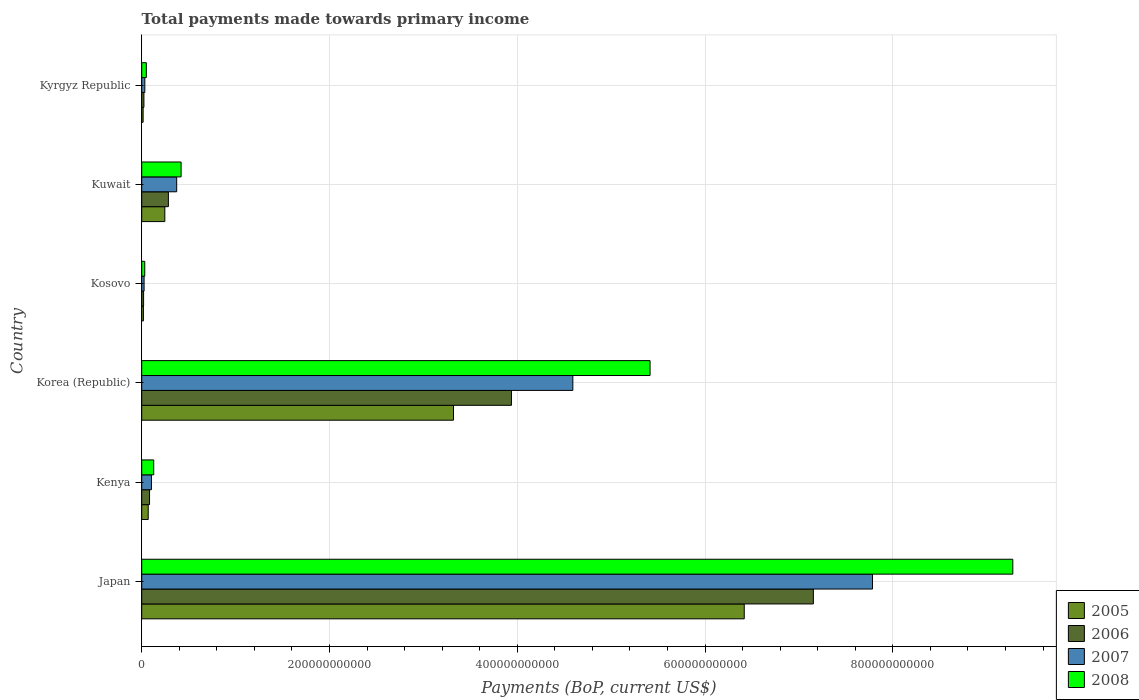How many groups of bars are there?
Your response must be concise. 6. Are the number of bars per tick equal to the number of legend labels?
Offer a very short reply. Yes. How many bars are there on the 5th tick from the top?
Ensure brevity in your answer.  4. How many bars are there on the 4th tick from the bottom?
Offer a very short reply. 4. What is the label of the 3rd group of bars from the top?
Provide a succinct answer. Kosovo. In how many cases, is the number of bars for a given country not equal to the number of legend labels?
Your response must be concise. 0. What is the total payments made towards primary income in 2008 in Japan?
Your answer should be compact. 9.28e+11. Across all countries, what is the maximum total payments made towards primary income in 2005?
Offer a terse response. 6.42e+11. Across all countries, what is the minimum total payments made towards primary income in 2008?
Your response must be concise. 3.22e+09. In which country was the total payments made towards primary income in 2007 maximum?
Provide a succinct answer. Japan. In which country was the total payments made towards primary income in 2006 minimum?
Your answer should be very brief. Kosovo. What is the total total payments made towards primary income in 2008 in the graph?
Your answer should be very brief. 1.53e+12. What is the difference between the total payments made towards primary income in 2008 in Kuwait and that in Kyrgyz Republic?
Make the answer very short. 3.70e+1. What is the difference between the total payments made towards primary income in 2006 in Japan and the total payments made towards primary income in 2005 in Korea (Republic)?
Give a very brief answer. 3.83e+11. What is the average total payments made towards primary income in 2008 per country?
Your answer should be very brief. 2.55e+11. What is the difference between the total payments made towards primary income in 2006 and total payments made towards primary income in 2007 in Kuwait?
Your answer should be compact. -8.83e+09. In how many countries, is the total payments made towards primary income in 2008 greater than 720000000000 US$?
Your response must be concise. 1. What is the ratio of the total payments made towards primary income in 2006 in Kenya to that in Kyrgyz Republic?
Your response must be concise. 3.56. Is the difference between the total payments made towards primary income in 2006 in Japan and Kuwait greater than the difference between the total payments made towards primary income in 2007 in Japan and Kuwait?
Give a very brief answer. No. What is the difference between the highest and the second highest total payments made towards primary income in 2006?
Provide a short and direct response. 3.22e+11. What is the difference between the highest and the lowest total payments made towards primary income in 2006?
Make the answer very short. 7.13e+11. How many bars are there?
Make the answer very short. 24. Are all the bars in the graph horizontal?
Provide a short and direct response. Yes. How many countries are there in the graph?
Your answer should be very brief. 6. What is the difference between two consecutive major ticks on the X-axis?
Ensure brevity in your answer.  2.00e+11. How many legend labels are there?
Ensure brevity in your answer.  4. How are the legend labels stacked?
Ensure brevity in your answer.  Vertical. What is the title of the graph?
Ensure brevity in your answer.  Total payments made towards primary income. What is the label or title of the X-axis?
Provide a succinct answer. Payments (BoP, current US$). What is the Payments (BoP, current US$) in 2005 in Japan?
Keep it short and to the point. 6.42e+11. What is the Payments (BoP, current US$) in 2006 in Japan?
Offer a terse response. 7.15e+11. What is the Payments (BoP, current US$) in 2007 in Japan?
Provide a short and direct response. 7.78e+11. What is the Payments (BoP, current US$) of 2008 in Japan?
Your response must be concise. 9.28e+11. What is the Payments (BoP, current US$) of 2005 in Kenya?
Offer a terse response. 6.92e+09. What is the Payments (BoP, current US$) in 2006 in Kenya?
Give a very brief answer. 8.34e+09. What is the Payments (BoP, current US$) in 2007 in Kenya?
Ensure brevity in your answer.  1.04e+1. What is the Payments (BoP, current US$) in 2008 in Kenya?
Provide a succinct answer. 1.28e+1. What is the Payments (BoP, current US$) of 2005 in Korea (Republic)?
Provide a short and direct response. 3.32e+11. What is the Payments (BoP, current US$) in 2006 in Korea (Republic)?
Offer a terse response. 3.94e+11. What is the Payments (BoP, current US$) of 2007 in Korea (Republic)?
Offer a terse response. 4.59e+11. What is the Payments (BoP, current US$) of 2008 in Korea (Republic)?
Provide a short and direct response. 5.41e+11. What is the Payments (BoP, current US$) of 2005 in Kosovo?
Ensure brevity in your answer.  1.80e+09. What is the Payments (BoP, current US$) in 2006 in Kosovo?
Make the answer very short. 1.99e+09. What is the Payments (BoP, current US$) of 2007 in Kosovo?
Ensure brevity in your answer.  2.53e+09. What is the Payments (BoP, current US$) in 2008 in Kosovo?
Offer a terse response. 3.22e+09. What is the Payments (BoP, current US$) in 2005 in Kuwait?
Provide a short and direct response. 2.46e+1. What is the Payments (BoP, current US$) in 2006 in Kuwait?
Offer a very short reply. 2.84e+1. What is the Payments (BoP, current US$) of 2007 in Kuwait?
Offer a terse response. 3.72e+1. What is the Payments (BoP, current US$) of 2008 in Kuwait?
Ensure brevity in your answer.  4.19e+1. What is the Payments (BoP, current US$) of 2005 in Kyrgyz Republic?
Your response must be concise. 1.50e+09. What is the Payments (BoP, current US$) of 2006 in Kyrgyz Republic?
Give a very brief answer. 2.34e+09. What is the Payments (BoP, current US$) in 2007 in Kyrgyz Republic?
Offer a very short reply. 3.31e+09. What is the Payments (BoP, current US$) in 2008 in Kyrgyz Republic?
Offer a terse response. 4.91e+09. Across all countries, what is the maximum Payments (BoP, current US$) in 2005?
Keep it short and to the point. 6.42e+11. Across all countries, what is the maximum Payments (BoP, current US$) in 2006?
Offer a very short reply. 7.15e+11. Across all countries, what is the maximum Payments (BoP, current US$) of 2007?
Give a very brief answer. 7.78e+11. Across all countries, what is the maximum Payments (BoP, current US$) in 2008?
Ensure brevity in your answer.  9.28e+11. Across all countries, what is the minimum Payments (BoP, current US$) of 2005?
Provide a succinct answer. 1.50e+09. Across all countries, what is the minimum Payments (BoP, current US$) in 2006?
Offer a terse response. 1.99e+09. Across all countries, what is the minimum Payments (BoP, current US$) of 2007?
Offer a very short reply. 2.53e+09. Across all countries, what is the minimum Payments (BoP, current US$) of 2008?
Provide a short and direct response. 3.22e+09. What is the total Payments (BoP, current US$) in 2005 in the graph?
Your answer should be compact. 1.01e+12. What is the total Payments (BoP, current US$) of 2006 in the graph?
Ensure brevity in your answer.  1.15e+12. What is the total Payments (BoP, current US$) of 2007 in the graph?
Provide a short and direct response. 1.29e+12. What is the total Payments (BoP, current US$) in 2008 in the graph?
Give a very brief answer. 1.53e+12. What is the difference between the Payments (BoP, current US$) of 2005 in Japan and that in Kenya?
Make the answer very short. 6.35e+11. What is the difference between the Payments (BoP, current US$) of 2006 in Japan and that in Kenya?
Your answer should be very brief. 7.07e+11. What is the difference between the Payments (BoP, current US$) of 2007 in Japan and that in Kenya?
Your answer should be compact. 7.68e+11. What is the difference between the Payments (BoP, current US$) of 2008 in Japan and that in Kenya?
Offer a very short reply. 9.15e+11. What is the difference between the Payments (BoP, current US$) of 2005 in Japan and that in Korea (Republic)?
Offer a terse response. 3.10e+11. What is the difference between the Payments (BoP, current US$) in 2006 in Japan and that in Korea (Republic)?
Your answer should be very brief. 3.22e+11. What is the difference between the Payments (BoP, current US$) of 2007 in Japan and that in Korea (Republic)?
Offer a terse response. 3.19e+11. What is the difference between the Payments (BoP, current US$) in 2008 in Japan and that in Korea (Republic)?
Ensure brevity in your answer.  3.86e+11. What is the difference between the Payments (BoP, current US$) in 2005 in Japan and that in Kosovo?
Your response must be concise. 6.40e+11. What is the difference between the Payments (BoP, current US$) in 2006 in Japan and that in Kosovo?
Ensure brevity in your answer.  7.13e+11. What is the difference between the Payments (BoP, current US$) in 2007 in Japan and that in Kosovo?
Offer a very short reply. 7.76e+11. What is the difference between the Payments (BoP, current US$) of 2008 in Japan and that in Kosovo?
Your response must be concise. 9.25e+11. What is the difference between the Payments (BoP, current US$) in 2005 in Japan and that in Kuwait?
Provide a succinct answer. 6.17e+11. What is the difference between the Payments (BoP, current US$) in 2006 in Japan and that in Kuwait?
Offer a very short reply. 6.87e+11. What is the difference between the Payments (BoP, current US$) of 2007 in Japan and that in Kuwait?
Provide a succinct answer. 7.41e+11. What is the difference between the Payments (BoP, current US$) of 2008 in Japan and that in Kuwait?
Provide a succinct answer. 8.86e+11. What is the difference between the Payments (BoP, current US$) of 2005 in Japan and that in Kyrgyz Republic?
Provide a succinct answer. 6.40e+11. What is the difference between the Payments (BoP, current US$) of 2006 in Japan and that in Kyrgyz Republic?
Your answer should be compact. 7.13e+11. What is the difference between the Payments (BoP, current US$) of 2007 in Japan and that in Kyrgyz Republic?
Offer a very short reply. 7.75e+11. What is the difference between the Payments (BoP, current US$) in 2008 in Japan and that in Kyrgyz Republic?
Offer a very short reply. 9.23e+11. What is the difference between the Payments (BoP, current US$) of 2005 in Kenya and that in Korea (Republic)?
Make the answer very short. -3.25e+11. What is the difference between the Payments (BoP, current US$) of 2006 in Kenya and that in Korea (Republic)?
Provide a short and direct response. -3.85e+11. What is the difference between the Payments (BoP, current US$) in 2007 in Kenya and that in Korea (Republic)?
Keep it short and to the point. -4.49e+11. What is the difference between the Payments (BoP, current US$) of 2008 in Kenya and that in Korea (Republic)?
Give a very brief answer. -5.29e+11. What is the difference between the Payments (BoP, current US$) in 2005 in Kenya and that in Kosovo?
Offer a very short reply. 5.12e+09. What is the difference between the Payments (BoP, current US$) in 2006 in Kenya and that in Kosovo?
Keep it short and to the point. 6.35e+09. What is the difference between the Payments (BoP, current US$) in 2007 in Kenya and that in Kosovo?
Give a very brief answer. 7.84e+09. What is the difference between the Payments (BoP, current US$) of 2008 in Kenya and that in Kosovo?
Ensure brevity in your answer.  9.56e+09. What is the difference between the Payments (BoP, current US$) in 2005 in Kenya and that in Kuwait?
Provide a short and direct response. -1.77e+1. What is the difference between the Payments (BoP, current US$) of 2006 in Kenya and that in Kuwait?
Offer a terse response. -2.01e+1. What is the difference between the Payments (BoP, current US$) in 2007 in Kenya and that in Kuwait?
Offer a very short reply. -2.69e+1. What is the difference between the Payments (BoP, current US$) of 2008 in Kenya and that in Kuwait?
Your answer should be very brief. -2.92e+1. What is the difference between the Payments (BoP, current US$) of 2005 in Kenya and that in Kyrgyz Republic?
Your answer should be compact. 5.42e+09. What is the difference between the Payments (BoP, current US$) in 2006 in Kenya and that in Kyrgyz Republic?
Ensure brevity in your answer.  6.00e+09. What is the difference between the Payments (BoP, current US$) of 2007 in Kenya and that in Kyrgyz Republic?
Your response must be concise. 7.05e+09. What is the difference between the Payments (BoP, current US$) of 2008 in Kenya and that in Kyrgyz Republic?
Offer a very short reply. 7.87e+09. What is the difference between the Payments (BoP, current US$) of 2005 in Korea (Republic) and that in Kosovo?
Ensure brevity in your answer.  3.30e+11. What is the difference between the Payments (BoP, current US$) of 2006 in Korea (Republic) and that in Kosovo?
Offer a terse response. 3.92e+11. What is the difference between the Payments (BoP, current US$) of 2007 in Korea (Republic) and that in Kosovo?
Give a very brief answer. 4.57e+11. What is the difference between the Payments (BoP, current US$) of 2008 in Korea (Republic) and that in Kosovo?
Offer a terse response. 5.38e+11. What is the difference between the Payments (BoP, current US$) in 2005 in Korea (Republic) and that in Kuwait?
Your answer should be very brief. 3.07e+11. What is the difference between the Payments (BoP, current US$) of 2006 in Korea (Republic) and that in Kuwait?
Your response must be concise. 3.65e+11. What is the difference between the Payments (BoP, current US$) of 2007 in Korea (Republic) and that in Kuwait?
Keep it short and to the point. 4.22e+11. What is the difference between the Payments (BoP, current US$) of 2008 in Korea (Republic) and that in Kuwait?
Offer a terse response. 5.00e+11. What is the difference between the Payments (BoP, current US$) in 2005 in Korea (Republic) and that in Kyrgyz Republic?
Your answer should be compact. 3.31e+11. What is the difference between the Payments (BoP, current US$) in 2006 in Korea (Republic) and that in Kyrgyz Republic?
Offer a very short reply. 3.91e+11. What is the difference between the Payments (BoP, current US$) of 2007 in Korea (Republic) and that in Kyrgyz Republic?
Your answer should be very brief. 4.56e+11. What is the difference between the Payments (BoP, current US$) of 2008 in Korea (Republic) and that in Kyrgyz Republic?
Your answer should be very brief. 5.37e+11. What is the difference between the Payments (BoP, current US$) of 2005 in Kosovo and that in Kuwait?
Give a very brief answer. -2.28e+1. What is the difference between the Payments (BoP, current US$) in 2006 in Kosovo and that in Kuwait?
Ensure brevity in your answer.  -2.64e+1. What is the difference between the Payments (BoP, current US$) of 2007 in Kosovo and that in Kuwait?
Ensure brevity in your answer.  -3.47e+1. What is the difference between the Payments (BoP, current US$) in 2008 in Kosovo and that in Kuwait?
Make the answer very short. -3.87e+1. What is the difference between the Payments (BoP, current US$) in 2005 in Kosovo and that in Kyrgyz Republic?
Provide a succinct answer. 3.03e+08. What is the difference between the Payments (BoP, current US$) in 2006 in Kosovo and that in Kyrgyz Republic?
Offer a very short reply. -3.55e+08. What is the difference between the Payments (BoP, current US$) in 2007 in Kosovo and that in Kyrgyz Republic?
Offer a very short reply. -7.83e+08. What is the difference between the Payments (BoP, current US$) in 2008 in Kosovo and that in Kyrgyz Republic?
Give a very brief answer. -1.69e+09. What is the difference between the Payments (BoP, current US$) of 2005 in Kuwait and that in Kyrgyz Republic?
Ensure brevity in your answer.  2.31e+1. What is the difference between the Payments (BoP, current US$) of 2006 in Kuwait and that in Kyrgyz Republic?
Ensure brevity in your answer.  2.61e+1. What is the difference between the Payments (BoP, current US$) in 2007 in Kuwait and that in Kyrgyz Republic?
Your response must be concise. 3.39e+1. What is the difference between the Payments (BoP, current US$) of 2008 in Kuwait and that in Kyrgyz Republic?
Offer a terse response. 3.70e+1. What is the difference between the Payments (BoP, current US$) in 2005 in Japan and the Payments (BoP, current US$) in 2006 in Kenya?
Offer a terse response. 6.33e+11. What is the difference between the Payments (BoP, current US$) of 2005 in Japan and the Payments (BoP, current US$) of 2007 in Kenya?
Ensure brevity in your answer.  6.31e+11. What is the difference between the Payments (BoP, current US$) of 2005 in Japan and the Payments (BoP, current US$) of 2008 in Kenya?
Keep it short and to the point. 6.29e+11. What is the difference between the Payments (BoP, current US$) in 2006 in Japan and the Payments (BoP, current US$) in 2007 in Kenya?
Your response must be concise. 7.05e+11. What is the difference between the Payments (BoP, current US$) in 2006 in Japan and the Payments (BoP, current US$) in 2008 in Kenya?
Provide a succinct answer. 7.03e+11. What is the difference between the Payments (BoP, current US$) of 2007 in Japan and the Payments (BoP, current US$) of 2008 in Kenya?
Offer a terse response. 7.66e+11. What is the difference between the Payments (BoP, current US$) of 2005 in Japan and the Payments (BoP, current US$) of 2006 in Korea (Republic)?
Your answer should be very brief. 2.48e+11. What is the difference between the Payments (BoP, current US$) of 2005 in Japan and the Payments (BoP, current US$) of 2007 in Korea (Republic)?
Your answer should be compact. 1.83e+11. What is the difference between the Payments (BoP, current US$) of 2005 in Japan and the Payments (BoP, current US$) of 2008 in Korea (Republic)?
Keep it short and to the point. 1.00e+11. What is the difference between the Payments (BoP, current US$) in 2006 in Japan and the Payments (BoP, current US$) in 2007 in Korea (Republic)?
Your answer should be very brief. 2.56e+11. What is the difference between the Payments (BoP, current US$) of 2006 in Japan and the Payments (BoP, current US$) of 2008 in Korea (Republic)?
Your answer should be compact. 1.74e+11. What is the difference between the Payments (BoP, current US$) in 2007 in Japan and the Payments (BoP, current US$) in 2008 in Korea (Republic)?
Ensure brevity in your answer.  2.37e+11. What is the difference between the Payments (BoP, current US$) in 2005 in Japan and the Payments (BoP, current US$) in 2006 in Kosovo?
Make the answer very short. 6.40e+11. What is the difference between the Payments (BoP, current US$) in 2005 in Japan and the Payments (BoP, current US$) in 2007 in Kosovo?
Offer a terse response. 6.39e+11. What is the difference between the Payments (BoP, current US$) of 2005 in Japan and the Payments (BoP, current US$) of 2008 in Kosovo?
Your answer should be very brief. 6.39e+11. What is the difference between the Payments (BoP, current US$) in 2006 in Japan and the Payments (BoP, current US$) in 2007 in Kosovo?
Offer a very short reply. 7.13e+11. What is the difference between the Payments (BoP, current US$) in 2006 in Japan and the Payments (BoP, current US$) in 2008 in Kosovo?
Offer a very short reply. 7.12e+11. What is the difference between the Payments (BoP, current US$) in 2007 in Japan and the Payments (BoP, current US$) in 2008 in Kosovo?
Make the answer very short. 7.75e+11. What is the difference between the Payments (BoP, current US$) in 2005 in Japan and the Payments (BoP, current US$) in 2006 in Kuwait?
Your response must be concise. 6.13e+11. What is the difference between the Payments (BoP, current US$) of 2005 in Japan and the Payments (BoP, current US$) of 2007 in Kuwait?
Provide a short and direct response. 6.05e+11. What is the difference between the Payments (BoP, current US$) of 2005 in Japan and the Payments (BoP, current US$) of 2008 in Kuwait?
Your response must be concise. 6.00e+11. What is the difference between the Payments (BoP, current US$) in 2006 in Japan and the Payments (BoP, current US$) in 2007 in Kuwait?
Offer a very short reply. 6.78e+11. What is the difference between the Payments (BoP, current US$) of 2006 in Japan and the Payments (BoP, current US$) of 2008 in Kuwait?
Give a very brief answer. 6.73e+11. What is the difference between the Payments (BoP, current US$) in 2007 in Japan and the Payments (BoP, current US$) in 2008 in Kuwait?
Your answer should be compact. 7.36e+11. What is the difference between the Payments (BoP, current US$) of 2005 in Japan and the Payments (BoP, current US$) of 2006 in Kyrgyz Republic?
Provide a short and direct response. 6.39e+11. What is the difference between the Payments (BoP, current US$) of 2005 in Japan and the Payments (BoP, current US$) of 2007 in Kyrgyz Republic?
Offer a terse response. 6.38e+11. What is the difference between the Payments (BoP, current US$) in 2005 in Japan and the Payments (BoP, current US$) in 2008 in Kyrgyz Republic?
Provide a succinct answer. 6.37e+11. What is the difference between the Payments (BoP, current US$) of 2006 in Japan and the Payments (BoP, current US$) of 2007 in Kyrgyz Republic?
Give a very brief answer. 7.12e+11. What is the difference between the Payments (BoP, current US$) in 2006 in Japan and the Payments (BoP, current US$) in 2008 in Kyrgyz Republic?
Your answer should be compact. 7.10e+11. What is the difference between the Payments (BoP, current US$) of 2007 in Japan and the Payments (BoP, current US$) of 2008 in Kyrgyz Republic?
Your response must be concise. 7.73e+11. What is the difference between the Payments (BoP, current US$) in 2005 in Kenya and the Payments (BoP, current US$) in 2006 in Korea (Republic)?
Your response must be concise. -3.87e+11. What is the difference between the Payments (BoP, current US$) of 2005 in Kenya and the Payments (BoP, current US$) of 2007 in Korea (Republic)?
Your answer should be compact. -4.52e+11. What is the difference between the Payments (BoP, current US$) of 2005 in Kenya and the Payments (BoP, current US$) of 2008 in Korea (Republic)?
Ensure brevity in your answer.  -5.35e+11. What is the difference between the Payments (BoP, current US$) in 2006 in Kenya and the Payments (BoP, current US$) in 2007 in Korea (Republic)?
Your answer should be compact. -4.51e+11. What is the difference between the Payments (BoP, current US$) in 2006 in Kenya and the Payments (BoP, current US$) in 2008 in Korea (Republic)?
Make the answer very short. -5.33e+11. What is the difference between the Payments (BoP, current US$) of 2007 in Kenya and the Payments (BoP, current US$) of 2008 in Korea (Republic)?
Your answer should be compact. -5.31e+11. What is the difference between the Payments (BoP, current US$) in 2005 in Kenya and the Payments (BoP, current US$) in 2006 in Kosovo?
Your answer should be compact. 4.93e+09. What is the difference between the Payments (BoP, current US$) in 2005 in Kenya and the Payments (BoP, current US$) in 2007 in Kosovo?
Offer a very short reply. 4.39e+09. What is the difference between the Payments (BoP, current US$) in 2005 in Kenya and the Payments (BoP, current US$) in 2008 in Kosovo?
Provide a short and direct response. 3.70e+09. What is the difference between the Payments (BoP, current US$) in 2006 in Kenya and the Payments (BoP, current US$) in 2007 in Kosovo?
Ensure brevity in your answer.  5.81e+09. What is the difference between the Payments (BoP, current US$) of 2006 in Kenya and the Payments (BoP, current US$) of 2008 in Kosovo?
Your answer should be compact. 5.12e+09. What is the difference between the Payments (BoP, current US$) in 2007 in Kenya and the Payments (BoP, current US$) in 2008 in Kosovo?
Make the answer very short. 7.14e+09. What is the difference between the Payments (BoP, current US$) in 2005 in Kenya and the Payments (BoP, current US$) in 2006 in Kuwait?
Make the answer very short. -2.15e+1. What is the difference between the Payments (BoP, current US$) in 2005 in Kenya and the Payments (BoP, current US$) in 2007 in Kuwait?
Provide a succinct answer. -3.03e+1. What is the difference between the Payments (BoP, current US$) of 2005 in Kenya and the Payments (BoP, current US$) of 2008 in Kuwait?
Offer a very short reply. -3.50e+1. What is the difference between the Payments (BoP, current US$) in 2006 in Kenya and the Payments (BoP, current US$) in 2007 in Kuwait?
Your answer should be very brief. -2.89e+1. What is the difference between the Payments (BoP, current US$) in 2006 in Kenya and the Payments (BoP, current US$) in 2008 in Kuwait?
Offer a terse response. -3.36e+1. What is the difference between the Payments (BoP, current US$) in 2007 in Kenya and the Payments (BoP, current US$) in 2008 in Kuwait?
Offer a very short reply. -3.16e+1. What is the difference between the Payments (BoP, current US$) in 2005 in Kenya and the Payments (BoP, current US$) in 2006 in Kyrgyz Republic?
Ensure brevity in your answer.  4.58e+09. What is the difference between the Payments (BoP, current US$) of 2005 in Kenya and the Payments (BoP, current US$) of 2007 in Kyrgyz Republic?
Offer a very short reply. 3.61e+09. What is the difference between the Payments (BoP, current US$) in 2005 in Kenya and the Payments (BoP, current US$) in 2008 in Kyrgyz Republic?
Offer a terse response. 2.01e+09. What is the difference between the Payments (BoP, current US$) of 2006 in Kenya and the Payments (BoP, current US$) of 2007 in Kyrgyz Republic?
Provide a short and direct response. 5.03e+09. What is the difference between the Payments (BoP, current US$) of 2006 in Kenya and the Payments (BoP, current US$) of 2008 in Kyrgyz Republic?
Your response must be concise. 3.43e+09. What is the difference between the Payments (BoP, current US$) in 2007 in Kenya and the Payments (BoP, current US$) in 2008 in Kyrgyz Republic?
Offer a terse response. 5.45e+09. What is the difference between the Payments (BoP, current US$) of 2005 in Korea (Republic) and the Payments (BoP, current US$) of 2006 in Kosovo?
Your response must be concise. 3.30e+11. What is the difference between the Payments (BoP, current US$) of 2005 in Korea (Republic) and the Payments (BoP, current US$) of 2007 in Kosovo?
Make the answer very short. 3.30e+11. What is the difference between the Payments (BoP, current US$) of 2005 in Korea (Republic) and the Payments (BoP, current US$) of 2008 in Kosovo?
Provide a short and direct response. 3.29e+11. What is the difference between the Payments (BoP, current US$) in 2006 in Korea (Republic) and the Payments (BoP, current US$) in 2007 in Kosovo?
Give a very brief answer. 3.91e+11. What is the difference between the Payments (BoP, current US$) of 2006 in Korea (Republic) and the Payments (BoP, current US$) of 2008 in Kosovo?
Offer a terse response. 3.91e+11. What is the difference between the Payments (BoP, current US$) in 2007 in Korea (Republic) and the Payments (BoP, current US$) in 2008 in Kosovo?
Keep it short and to the point. 4.56e+11. What is the difference between the Payments (BoP, current US$) of 2005 in Korea (Republic) and the Payments (BoP, current US$) of 2006 in Kuwait?
Provide a short and direct response. 3.04e+11. What is the difference between the Payments (BoP, current US$) of 2005 in Korea (Republic) and the Payments (BoP, current US$) of 2007 in Kuwait?
Give a very brief answer. 2.95e+11. What is the difference between the Payments (BoP, current US$) of 2005 in Korea (Republic) and the Payments (BoP, current US$) of 2008 in Kuwait?
Provide a short and direct response. 2.90e+11. What is the difference between the Payments (BoP, current US$) of 2006 in Korea (Republic) and the Payments (BoP, current US$) of 2007 in Kuwait?
Make the answer very short. 3.57e+11. What is the difference between the Payments (BoP, current US$) in 2006 in Korea (Republic) and the Payments (BoP, current US$) in 2008 in Kuwait?
Make the answer very short. 3.52e+11. What is the difference between the Payments (BoP, current US$) in 2007 in Korea (Republic) and the Payments (BoP, current US$) in 2008 in Kuwait?
Provide a succinct answer. 4.17e+11. What is the difference between the Payments (BoP, current US$) in 2005 in Korea (Republic) and the Payments (BoP, current US$) in 2006 in Kyrgyz Republic?
Give a very brief answer. 3.30e+11. What is the difference between the Payments (BoP, current US$) in 2005 in Korea (Republic) and the Payments (BoP, current US$) in 2007 in Kyrgyz Republic?
Provide a short and direct response. 3.29e+11. What is the difference between the Payments (BoP, current US$) of 2005 in Korea (Republic) and the Payments (BoP, current US$) of 2008 in Kyrgyz Republic?
Offer a terse response. 3.27e+11. What is the difference between the Payments (BoP, current US$) of 2006 in Korea (Republic) and the Payments (BoP, current US$) of 2007 in Kyrgyz Republic?
Provide a short and direct response. 3.91e+11. What is the difference between the Payments (BoP, current US$) of 2006 in Korea (Republic) and the Payments (BoP, current US$) of 2008 in Kyrgyz Republic?
Provide a short and direct response. 3.89e+11. What is the difference between the Payments (BoP, current US$) in 2007 in Korea (Republic) and the Payments (BoP, current US$) in 2008 in Kyrgyz Republic?
Provide a succinct answer. 4.54e+11. What is the difference between the Payments (BoP, current US$) in 2005 in Kosovo and the Payments (BoP, current US$) in 2006 in Kuwait?
Your response must be concise. -2.66e+1. What is the difference between the Payments (BoP, current US$) of 2005 in Kosovo and the Payments (BoP, current US$) of 2007 in Kuwait?
Provide a succinct answer. -3.54e+1. What is the difference between the Payments (BoP, current US$) of 2005 in Kosovo and the Payments (BoP, current US$) of 2008 in Kuwait?
Make the answer very short. -4.01e+1. What is the difference between the Payments (BoP, current US$) of 2006 in Kosovo and the Payments (BoP, current US$) of 2007 in Kuwait?
Ensure brevity in your answer.  -3.53e+1. What is the difference between the Payments (BoP, current US$) in 2006 in Kosovo and the Payments (BoP, current US$) in 2008 in Kuwait?
Provide a short and direct response. -3.99e+1. What is the difference between the Payments (BoP, current US$) in 2007 in Kosovo and the Payments (BoP, current US$) in 2008 in Kuwait?
Make the answer very short. -3.94e+1. What is the difference between the Payments (BoP, current US$) in 2005 in Kosovo and the Payments (BoP, current US$) in 2006 in Kyrgyz Republic?
Make the answer very short. -5.39e+08. What is the difference between the Payments (BoP, current US$) of 2005 in Kosovo and the Payments (BoP, current US$) of 2007 in Kyrgyz Republic?
Keep it short and to the point. -1.51e+09. What is the difference between the Payments (BoP, current US$) of 2005 in Kosovo and the Payments (BoP, current US$) of 2008 in Kyrgyz Republic?
Your response must be concise. -3.11e+09. What is the difference between the Payments (BoP, current US$) of 2006 in Kosovo and the Payments (BoP, current US$) of 2007 in Kyrgyz Republic?
Your response must be concise. -1.32e+09. What is the difference between the Payments (BoP, current US$) in 2006 in Kosovo and the Payments (BoP, current US$) in 2008 in Kyrgyz Republic?
Offer a terse response. -2.93e+09. What is the difference between the Payments (BoP, current US$) in 2007 in Kosovo and the Payments (BoP, current US$) in 2008 in Kyrgyz Republic?
Keep it short and to the point. -2.38e+09. What is the difference between the Payments (BoP, current US$) of 2005 in Kuwait and the Payments (BoP, current US$) of 2006 in Kyrgyz Republic?
Make the answer very short. 2.23e+1. What is the difference between the Payments (BoP, current US$) in 2005 in Kuwait and the Payments (BoP, current US$) in 2007 in Kyrgyz Republic?
Provide a short and direct response. 2.13e+1. What is the difference between the Payments (BoP, current US$) in 2005 in Kuwait and the Payments (BoP, current US$) in 2008 in Kyrgyz Republic?
Your answer should be very brief. 1.97e+1. What is the difference between the Payments (BoP, current US$) of 2006 in Kuwait and the Payments (BoP, current US$) of 2007 in Kyrgyz Republic?
Your answer should be compact. 2.51e+1. What is the difference between the Payments (BoP, current US$) of 2006 in Kuwait and the Payments (BoP, current US$) of 2008 in Kyrgyz Republic?
Your answer should be very brief. 2.35e+1. What is the difference between the Payments (BoP, current US$) of 2007 in Kuwait and the Payments (BoP, current US$) of 2008 in Kyrgyz Republic?
Offer a very short reply. 3.23e+1. What is the average Payments (BoP, current US$) of 2005 per country?
Provide a short and direct response. 1.68e+11. What is the average Payments (BoP, current US$) in 2006 per country?
Keep it short and to the point. 1.92e+11. What is the average Payments (BoP, current US$) in 2007 per country?
Ensure brevity in your answer.  2.15e+11. What is the average Payments (BoP, current US$) of 2008 per country?
Make the answer very short. 2.55e+11. What is the difference between the Payments (BoP, current US$) in 2005 and Payments (BoP, current US$) in 2006 in Japan?
Provide a short and direct response. -7.36e+1. What is the difference between the Payments (BoP, current US$) in 2005 and Payments (BoP, current US$) in 2007 in Japan?
Your answer should be very brief. -1.37e+11. What is the difference between the Payments (BoP, current US$) in 2005 and Payments (BoP, current US$) in 2008 in Japan?
Offer a very short reply. -2.86e+11. What is the difference between the Payments (BoP, current US$) in 2006 and Payments (BoP, current US$) in 2007 in Japan?
Your answer should be compact. -6.30e+1. What is the difference between the Payments (BoP, current US$) in 2006 and Payments (BoP, current US$) in 2008 in Japan?
Offer a very short reply. -2.12e+11. What is the difference between the Payments (BoP, current US$) in 2007 and Payments (BoP, current US$) in 2008 in Japan?
Give a very brief answer. -1.49e+11. What is the difference between the Payments (BoP, current US$) of 2005 and Payments (BoP, current US$) of 2006 in Kenya?
Your answer should be compact. -1.42e+09. What is the difference between the Payments (BoP, current US$) of 2005 and Payments (BoP, current US$) of 2007 in Kenya?
Give a very brief answer. -3.44e+09. What is the difference between the Payments (BoP, current US$) in 2005 and Payments (BoP, current US$) in 2008 in Kenya?
Make the answer very short. -5.86e+09. What is the difference between the Payments (BoP, current US$) in 2006 and Payments (BoP, current US$) in 2007 in Kenya?
Your answer should be compact. -2.02e+09. What is the difference between the Payments (BoP, current US$) in 2006 and Payments (BoP, current US$) in 2008 in Kenya?
Your answer should be compact. -4.44e+09. What is the difference between the Payments (BoP, current US$) of 2007 and Payments (BoP, current US$) of 2008 in Kenya?
Your answer should be very brief. -2.42e+09. What is the difference between the Payments (BoP, current US$) in 2005 and Payments (BoP, current US$) in 2006 in Korea (Republic)?
Keep it short and to the point. -6.17e+1. What is the difference between the Payments (BoP, current US$) in 2005 and Payments (BoP, current US$) in 2007 in Korea (Republic)?
Offer a terse response. -1.27e+11. What is the difference between the Payments (BoP, current US$) in 2005 and Payments (BoP, current US$) in 2008 in Korea (Republic)?
Keep it short and to the point. -2.09e+11. What is the difference between the Payments (BoP, current US$) of 2006 and Payments (BoP, current US$) of 2007 in Korea (Republic)?
Your response must be concise. -6.54e+1. What is the difference between the Payments (BoP, current US$) in 2006 and Payments (BoP, current US$) in 2008 in Korea (Republic)?
Keep it short and to the point. -1.48e+11. What is the difference between the Payments (BoP, current US$) of 2007 and Payments (BoP, current US$) of 2008 in Korea (Republic)?
Your response must be concise. -8.22e+1. What is the difference between the Payments (BoP, current US$) of 2005 and Payments (BoP, current US$) of 2006 in Kosovo?
Give a very brief answer. -1.83e+08. What is the difference between the Payments (BoP, current US$) in 2005 and Payments (BoP, current US$) in 2007 in Kosovo?
Your response must be concise. -7.24e+08. What is the difference between the Payments (BoP, current US$) of 2005 and Payments (BoP, current US$) of 2008 in Kosovo?
Offer a terse response. -1.42e+09. What is the difference between the Payments (BoP, current US$) in 2006 and Payments (BoP, current US$) in 2007 in Kosovo?
Offer a very short reply. -5.41e+08. What is the difference between the Payments (BoP, current US$) in 2006 and Payments (BoP, current US$) in 2008 in Kosovo?
Ensure brevity in your answer.  -1.24e+09. What is the difference between the Payments (BoP, current US$) of 2007 and Payments (BoP, current US$) of 2008 in Kosovo?
Your answer should be compact. -6.94e+08. What is the difference between the Payments (BoP, current US$) of 2005 and Payments (BoP, current US$) of 2006 in Kuwait?
Give a very brief answer. -3.80e+09. What is the difference between the Payments (BoP, current US$) of 2005 and Payments (BoP, current US$) of 2007 in Kuwait?
Provide a succinct answer. -1.26e+1. What is the difference between the Payments (BoP, current US$) of 2005 and Payments (BoP, current US$) of 2008 in Kuwait?
Provide a short and direct response. -1.73e+1. What is the difference between the Payments (BoP, current US$) of 2006 and Payments (BoP, current US$) of 2007 in Kuwait?
Offer a terse response. -8.83e+09. What is the difference between the Payments (BoP, current US$) of 2006 and Payments (BoP, current US$) of 2008 in Kuwait?
Provide a succinct answer. -1.35e+1. What is the difference between the Payments (BoP, current US$) in 2007 and Payments (BoP, current US$) in 2008 in Kuwait?
Keep it short and to the point. -4.70e+09. What is the difference between the Payments (BoP, current US$) of 2005 and Payments (BoP, current US$) of 2006 in Kyrgyz Republic?
Offer a very short reply. -8.41e+08. What is the difference between the Payments (BoP, current US$) of 2005 and Payments (BoP, current US$) of 2007 in Kyrgyz Republic?
Your response must be concise. -1.81e+09. What is the difference between the Payments (BoP, current US$) in 2005 and Payments (BoP, current US$) in 2008 in Kyrgyz Republic?
Provide a short and direct response. -3.41e+09. What is the difference between the Payments (BoP, current US$) in 2006 and Payments (BoP, current US$) in 2007 in Kyrgyz Republic?
Your answer should be very brief. -9.69e+08. What is the difference between the Payments (BoP, current US$) in 2006 and Payments (BoP, current US$) in 2008 in Kyrgyz Republic?
Your answer should be very brief. -2.57e+09. What is the difference between the Payments (BoP, current US$) of 2007 and Payments (BoP, current US$) of 2008 in Kyrgyz Republic?
Keep it short and to the point. -1.60e+09. What is the ratio of the Payments (BoP, current US$) in 2005 in Japan to that in Kenya?
Provide a succinct answer. 92.74. What is the ratio of the Payments (BoP, current US$) in 2006 in Japan to that in Kenya?
Offer a terse response. 85.77. What is the ratio of the Payments (BoP, current US$) in 2007 in Japan to that in Kenya?
Your answer should be compact. 75.11. What is the ratio of the Payments (BoP, current US$) in 2008 in Japan to that in Kenya?
Your answer should be very brief. 72.6. What is the ratio of the Payments (BoP, current US$) in 2005 in Japan to that in Korea (Republic)?
Provide a short and direct response. 1.93. What is the ratio of the Payments (BoP, current US$) in 2006 in Japan to that in Korea (Republic)?
Provide a succinct answer. 1.82. What is the ratio of the Payments (BoP, current US$) in 2007 in Japan to that in Korea (Republic)?
Your answer should be very brief. 1.7. What is the ratio of the Payments (BoP, current US$) in 2008 in Japan to that in Korea (Republic)?
Offer a very short reply. 1.71. What is the ratio of the Payments (BoP, current US$) of 2005 in Japan to that in Kosovo?
Your response must be concise. 355.86. What is the ratio of the Payments (BoP, current US$) in 2006 in Japan to that in Kosovo?
Ensure brevity in your answer.  360.13. What is the ratio of the Payments (BoP, current US$) of 2007 in Japan to that in Kosovo?
Your response must be concise. 307.92. What is the ratio of the Payments (BoP, current US$) in 2008 in Japan to that in Kosovo?
Provide a short and direct response. 287.94. What is the ratio of the Payments (BoP, current US$) in 2005 in Japan to that in Kuwait?
Keep it short and to the point. 26.08. What is the ratio of the Payments (BoP, current US$) of 2006 in Japan to that in Kuwait?
Your answer should be very brief. 25.18. What is the ratio of the Payments (BoP, current US$) in 2007 in Japan to that in Kuwait?
Your answer should be compact. 20.9. What is the ratio of the Payments (BoP, current US$) in 2008 in Japan to that in Kuwait?
Your response must be concise. 22.13. What is the ratio of the Payments (BoP, current US$) of 2005 in Japan to that in Kyrgyz Republic?
Your answer should be compact. 427.7. What is the ratio of the Payments (BoP, current US$) in 2006 in Japan to that in Kyrgyz Republic?
Provide a short and direct response. 305.47. What is the ratio of the Payments (BoP, current US$) of 2007 in Japan to that in Kyrgyz Republic?
Make the answer very short. 235.06. What is the ratio of the Payments (BoP, current US$) of 2008 in Japan to that in Kyrgyz Republic?
Provide a short and direct response. 188.9. What is the ratio of the Payments (BoP, current US$) in 2005 in Kenya to that in Korea (Republic)?
Give a very brief answer. 0.02. What is the ratio of the Payments (BoP, current US$) in 2006 in Kenya to that in Korea (Republic)?
Your response must be concise. 0.02. What is the ratio of the Payments (BoP, current US$) in 2007 in Kenya to that in Korea (Republic)?
Your answer should be very brief. 0.02. What is the ratio of the Payments (BoP, current US$) of 2008 in Kenya to that in Korea (Republic)?
Your answer should be compact. 0.02. What is the ratio of the Payments (BoP, current US$) in 2005 in Kenya to that in Kosovo?
Your answer should be very brief. 3.84. What is the ratio of the Payments (BoP, current US$) in 2006 in Kenya to that in Kosovo?
Your answer should be compact. 4.2. What is the ratio of the Payments (BoP, current US$) of 2007 in Kenya to that in Kosovo?
Your answer should be very brief. 4.1. What is the ratio of the Payments (BoP, current US$) in 2008 in Kenya to that in Kosovo?
Ensure brevity in your answer.  3.97. What is the ratio of the Payments (BoP, current US$) of 2005 in Kenya to that in Kuwait?
Ensure brevity in your answer.  0.28. What is the ratio of the Payments (BoP, current US$) of 2006 in Kenya to that in Kuwait?
Ensure brevity in your answer.  0.29. What is the ratio of the Payments (BoP, current US$) of 2007 in Kenya to that in Kuwait?
Your answer should be very brief. 0.28. What is the ratio of the Payments (BoP, current US$) in 2008 in Kenya to that in Kuwait?
Make the answer very short. 0.3. What is the ratio of the Payments (BoP, current US$) in 2005 in Kenya to that in Kyrgyz Republic?
Provide a succinct answer. 4.61. What is the ratio of the Payments (BoP, current US$) of 2006 in Kenya to that in Kyrgyz Republic?
Your response must be concise. 3.56. What is the ratio of the Payments (BoP, current US$) of 2007 in Kenya to that in Kyrgyz Republic?
Your response must be concise. 3.13. What is the ratio of the Payments (BoP, current US$) in 2008 in Kenya to that in Kyrgyz Republic?
Offer a terse response. 2.6. What is the ratio of the Payments (BoP, current US$) in 2005 in Korea (Republic) to that in Kosovo?
Ensure brevity in your answer.  184.13. What is the ratio of the Payments (BoP, current US$) in 2006 in Korea (Republic) to that in Kosovo?
Provide a short and direct response. 198.25. What is the ratio of the Payments (BoP, current US$) in 2007 in Korea (Republic) to that in Kosovo?
Keep it short and to the point. 181.66. What is the ratio of the Payments (BoP, current US$) of 2008 in Korea (Republic) to that in Kosovo?
Your answer should be very brief. 168.03. What is the ratio of the Payments (BoP, current US$) of 2005 in Korea (Republic) to that in Kuwait?
Your answer should be compact. 13.49. What is the ratio of the Payments (BoP, current US$) in 2006 in Korea (Republic) to that in Kuwait?
Provide a succinct answer. 13.86. What is the ratio of the Payments (BoP, current US$) in 2007 in Korea (Republic) to that in Kuwait?
Provide a succinct answer. 12.33. What is the ratio of the Payments (BoP, current US$) of 2008 in Korea (Republic) to that in Kuwait?
Your answer should be very brief. 12.91. What is the ratio of the Payments (BoP, current US$) of 2005 in Korea (Republic) to that in Kyrgyz Republic?
Give a very brief answer. 221.31. What is the ratio of the Payments (BoP, current US$) in 2006 in Korea (Republic) to that in Kyrgyz Republic?
Offer a terse response. 168.16. What is the ratio of the Payments (BoP, current US$) in 2007 in Korea (Republic) to that in Kyrgyz Republic?
Give a very brief answer. 138.68. What is the ratio of the Payments (BoP, current US$) in 2008 in Korea (Republic) to that in Kyrgyz Republic?
Offer a very short reply. 110.24. What is the ratio of the Payments (BoP, current US$) of 2005 in Kosovo to that in Kuwait?
Provide a succinct answer. 0.07. What is the ratio of the Payments (BoP, current US$) of 2006 in Kosovo to that in Kuwait?
Your response must be concise. 0.07. What is the ratio of the Payments (BoP, current US$) in 2007 in Kosovo to that in Kuwait?
Provide a short and direct response. 0.07. What is the ratio of the Payments (BoP, current US$) of 2008 in Kosovo to that in Kuwait?
Make the answer very short. 0.08. What is the ratio of the Payments (BoP, current US$) in 2005 in Kosovo to that in Kyrgyz Republic?
Give a very brief answer. 1.2. What is the ratio of the Payments (BoP, current US$) of 2006 in Kosovo to that in Kyrgyz Republic?
Keep it short and to the point. 0.85. What is the ratio of the Payments (BoP, current US$) of 2007 in Kosovo to that in Kyrgyz Republic?
Offer a very short reply. 0.76. What is the ratio of the Payments (BoP, current US$) in 2008 in Kosovo to that in Kyrgyz Republic?
Offer a very short reply. 0.66. What is the ratio of the Payments (BoP, current US$) of 2005 in Kuwait to that in Kyrgyz Republic?
Provide a short and direct response. 16.4. What is the ratio of the Payments (BoP, current US$) in 2006 in Kuwait to that in Kyrgyz Republic?
Keep it short and to the point. 12.13. What is the ratio of the Payments (BoP, current US$) in 2007 in Kuwait to that in Kyrgyz Republic?
Make the answer very short. 11.25. What is the ratio of the Payments (BoP, current US$) in 2008 in Kuwait to that in Kyrgyz Republic?
Make the answer very short. 8.54. What is the difference between the highest and the second highest Payments (BoP, current US$) in 2005?
Provide a succinct answer. 3.10e+11. What is the difference between the highest and the second highest Payments (BoP, current US$) of 2006?
Ensure brevity in your answer.  3.22e+11. What is the difference between the highest and the second highest Payments (BoP, current US$) in 2007?
Keep it short and to the point. 3.19e+11. What is the difference between the highest and the second highest Payments (BoP, current US$) of 2008?
Ensure brevity in your answer.  3.86e+11. What is the difference between the highest and the lowest Payments (BoP, current US$) in 2005?
Your answer should be compact. 6.40e+11. What is the difference between the highest and the lowest Payments (BoP, current US$) of 2006?
Provide a succinct answer. 7.13e+11. What is the difference between the highest and the lowest Payments (BoP, current US$) in 2007?
Your response must be concise. 7.76e+11. What is the difference between the highest and the lowest Payments (BoP, current US$) in 2008?
Make the answer very short. 9.25e+11. 